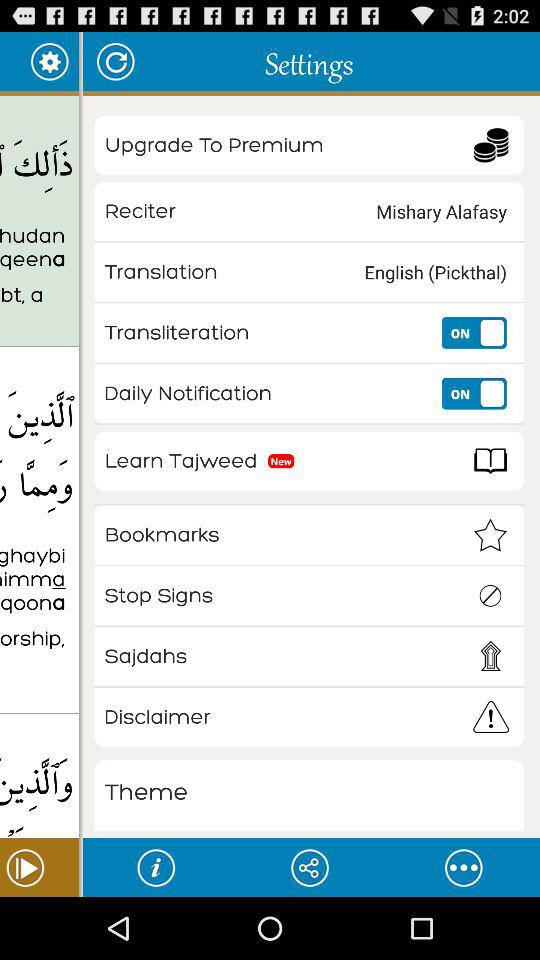What's the status of the "Daily Notification"? The status of the "Daily Notification" is "ON". 